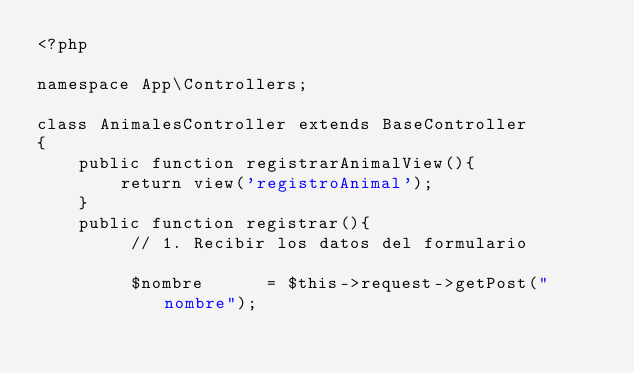Convert code to text. <code><loc_0><loc_0><loc_500><loc_500><_PHP_><?php

namespace App\Controllers;

class AnimalesController extends BaseController
{
    public function registrarAnimalView(){
        return view('registroAnimal');
    }
    public function registrar(){
         // 1. Recibir los datos del formulario

         $nombre      = $this->request->getPost("nombre");</code> 